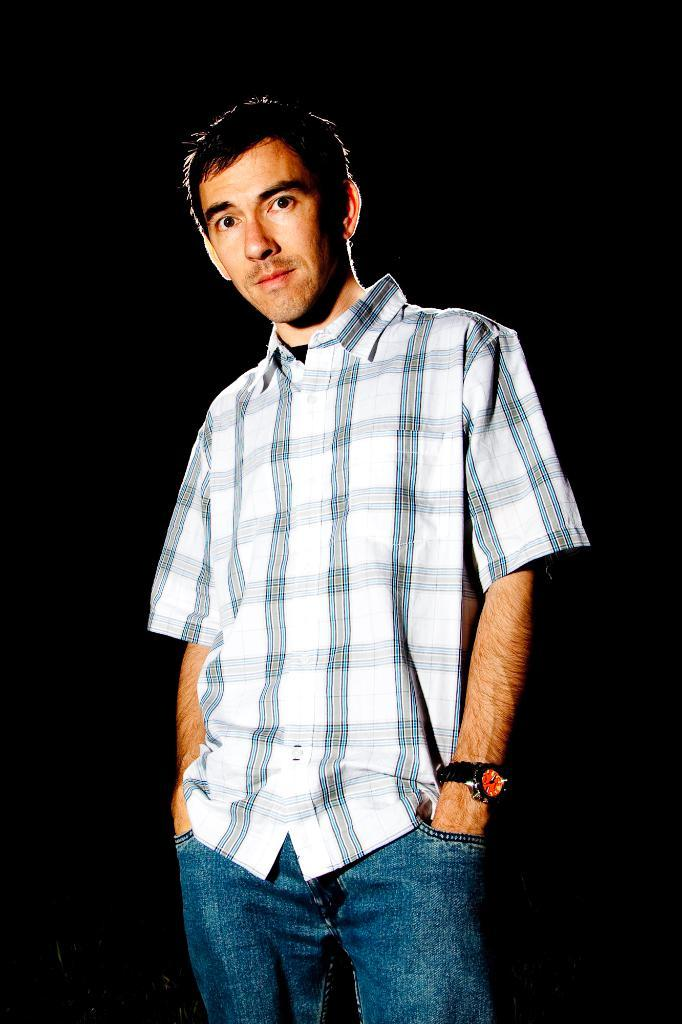What is the main subject of the image? There is a man standing in the image. Can you describe the background of the image? The background of the image is dark. What type of cemetery can be seen in the background of the image? There is no cemetery present in the image; the background is dark. Can you tell me how many airplanes are visible at the airport in the image? There is no airport present in the image; it features a man standing in a dark background. 